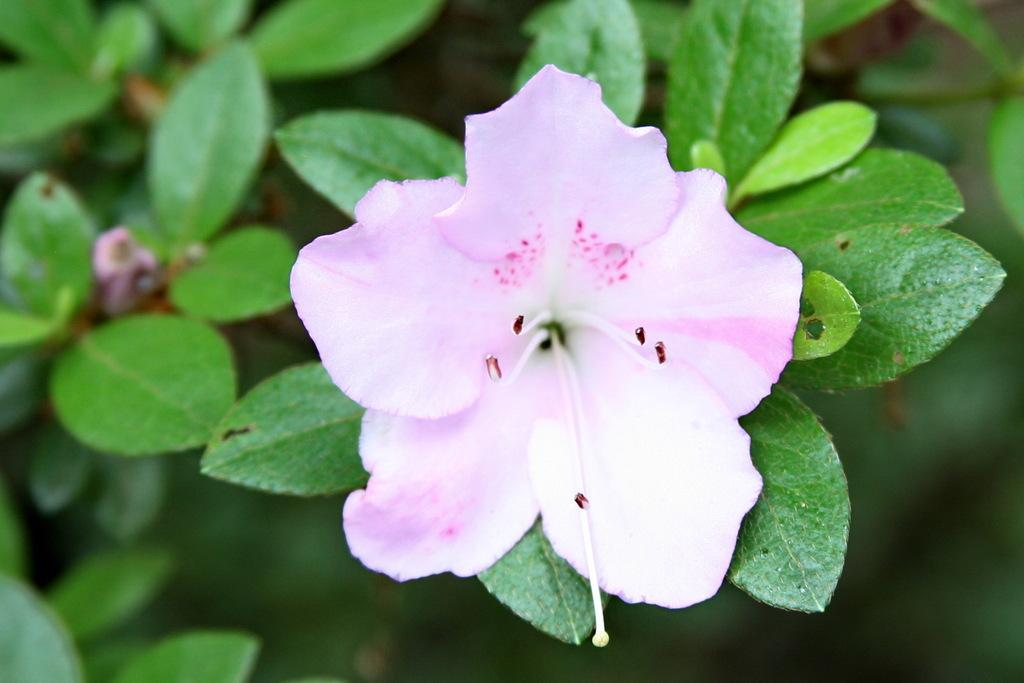What type of plant is visible in the image? There is a flower on a plant in the image. Can you describe the flower in more detail? Unfortunately, the image does not provide enough detail to describe the flower further. How many cushions are placed on the bridge in the image? There is no bridge or cushions present in the image; it only features a flower on a plant. 